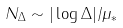Convert formula to latex. <formula><loc_0><loc_0><loc_500><loc_500>N _ { \Delta } \sim | \log \Delta | / \mu _ { * }</formula> 